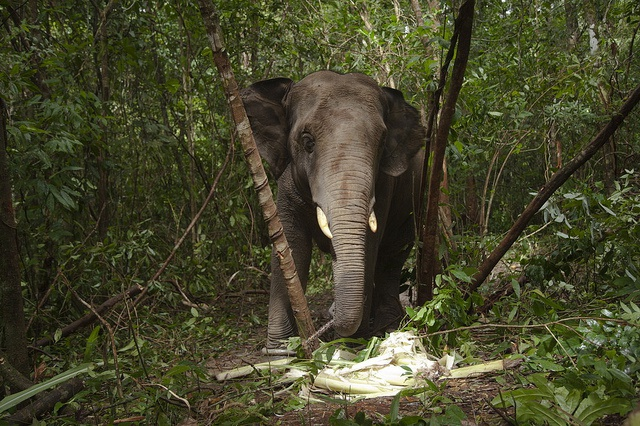Describe the objects in this image and their specific colors. I can see a elephant in black and gray tones in this image. 